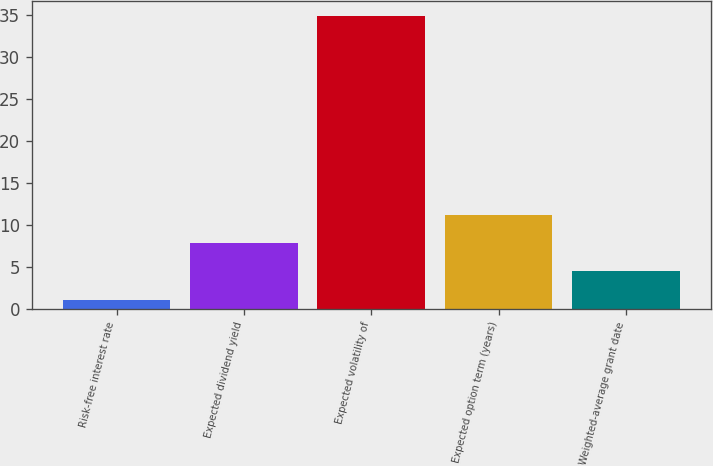Convert chart. <chart><loc_0><loc_0><loc_500><loc_500><bar_chart><fcel>Risk-free interest rate<fcel>Expected dividend yield<fcel>Expected volatility of<fcel>Expected option term (years)<fcel>Weighted-average grant date<nl><fcel>1.1<fcel>7.86<fcel>34.9<fcel>11.24<fcel>4.48<nl></chart> 